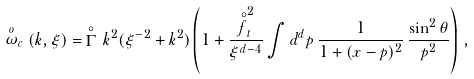<formula> <loc_0><loc_0><loc_500><loc_500>\stackrel { o } { \omega } _ { c } ( k , \xi ) = \, \stackrel { \circ } { \Gamma } \, k ^ { 2 } ( \xi ^ { - 2 } + k ^ { 2 } ) \left ( 1 + \frac { \stackrel { \circ } { f } _ { t } ^ { 2 } } { \xi ^ { d - 4 } } \int d ^ { d } p \, \frac { 1 } { 1 + ( { x } - { p } ) ^ { 2 } } \, \frac { \sin ^ { 2 } \theta } { p ^ { 2 } } \right ) \, ,</formula> 